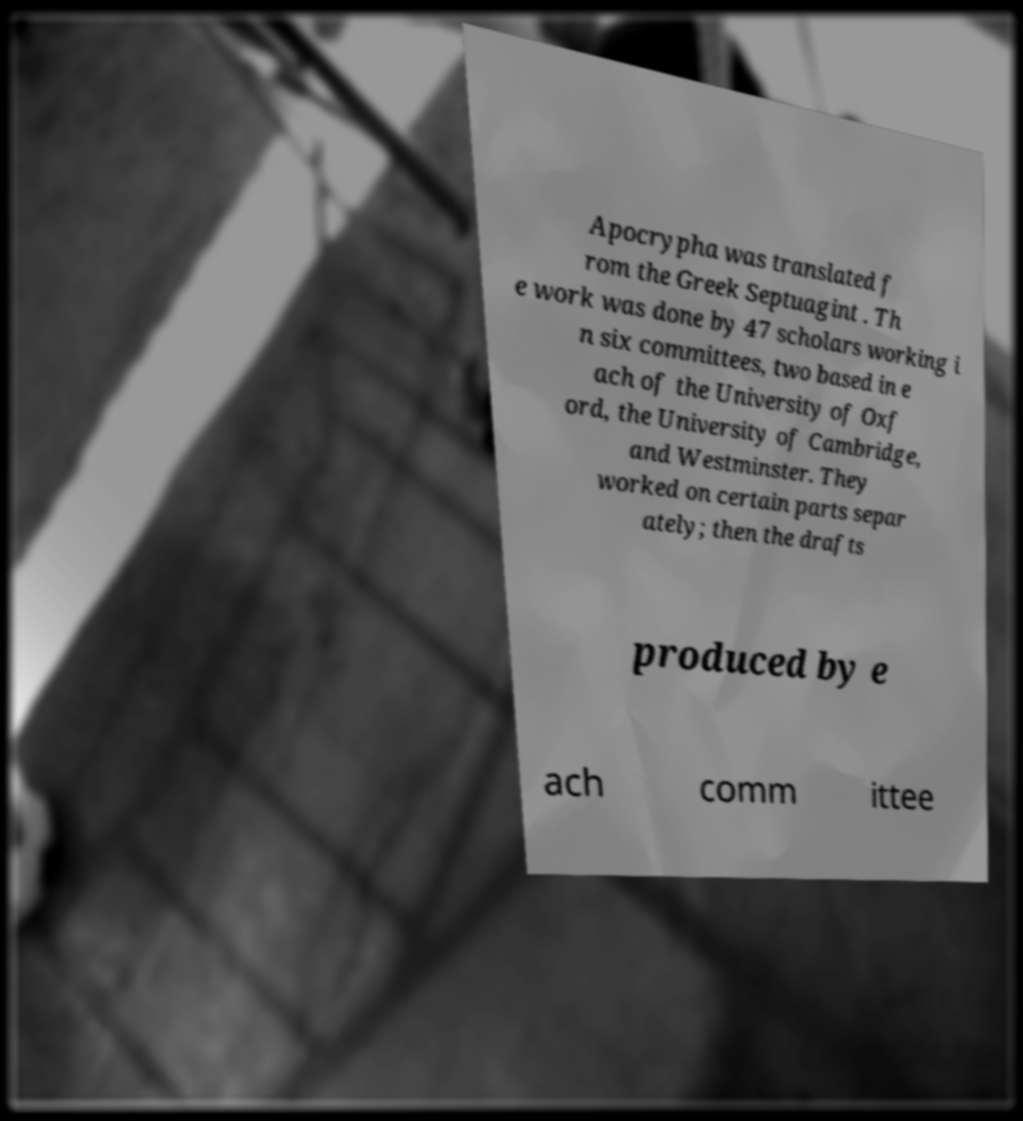There's text embedded in this image that I need extracted. Can you transcribe it verbatim? Apocrypha was translated f rom the Greek Septuagint . Th e work was done by 47 scholars working i n six committees, two based in e ach of the University of Oxf ord, the University of Cambridge, and Westminster. They worked on certain parts separ ately; then the drafts produced by e ach comm ittee 